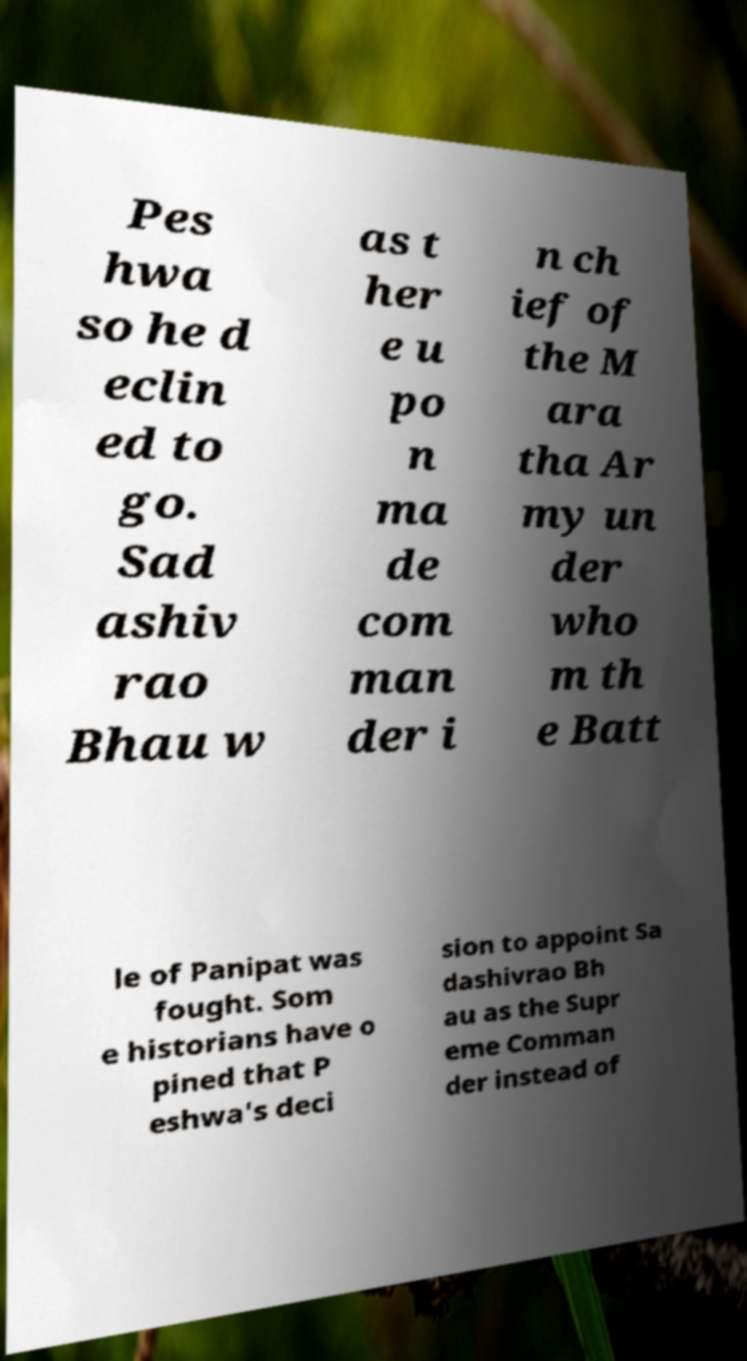There's text embedded in this image that I need extracted. Can you transcribe it verbatim? Pes hwa so he d eclin ed to go. Sad ashiv rao Bhau w as t her e u po n ma de com man der i n ch ief of the M ara tha Ar my un der who m th e Batt le of Panipat was fought. Som e historians have o pined that P eshwa's deci sion to appoint Sa dashivrao Bh au as the Supr eme Comman der instead of 